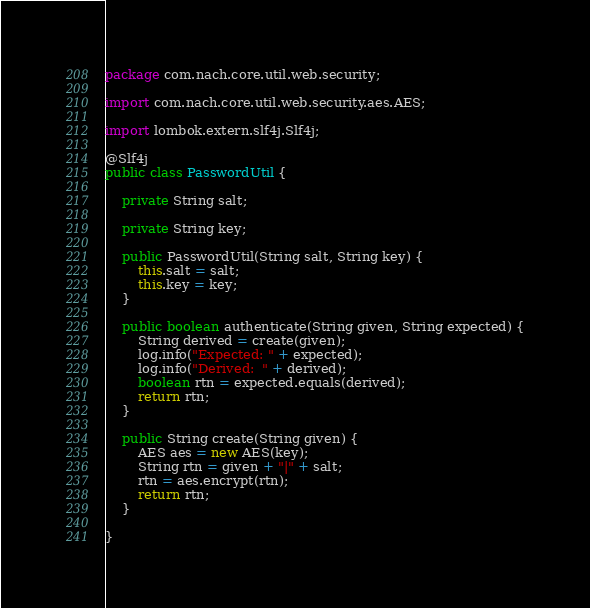<code> <loc_0><loc_0><loc_500><loc_500><_Java_>package com.nach.core.util.web.security;

import com.nach.core.util.web.security.aes.AES;

import lombok.extern.slf4j.Slf4j;

@Slf4j
public class PasswordUtil {

	private String salt;
	
	private String key;
	
	public PasswordUtil(String salt, String key) {
		this.salt = salt;
		this.key = key;
	}
	
	public boolean authenticate(String given, String expected) {
		String derived = create(given);
		log.info("Expected: " + expected);
		log.info("Derived:  " + derived);
		boolean rtn = expected.equals(derived);
		return rtn;
	}

	public String create(String given) {
		AES aes = new AES(key);
		String rtn = given + "|" + salt;
		rtn = aes.encrypt(rtn);
		return rtn;
	}

}
</code> 